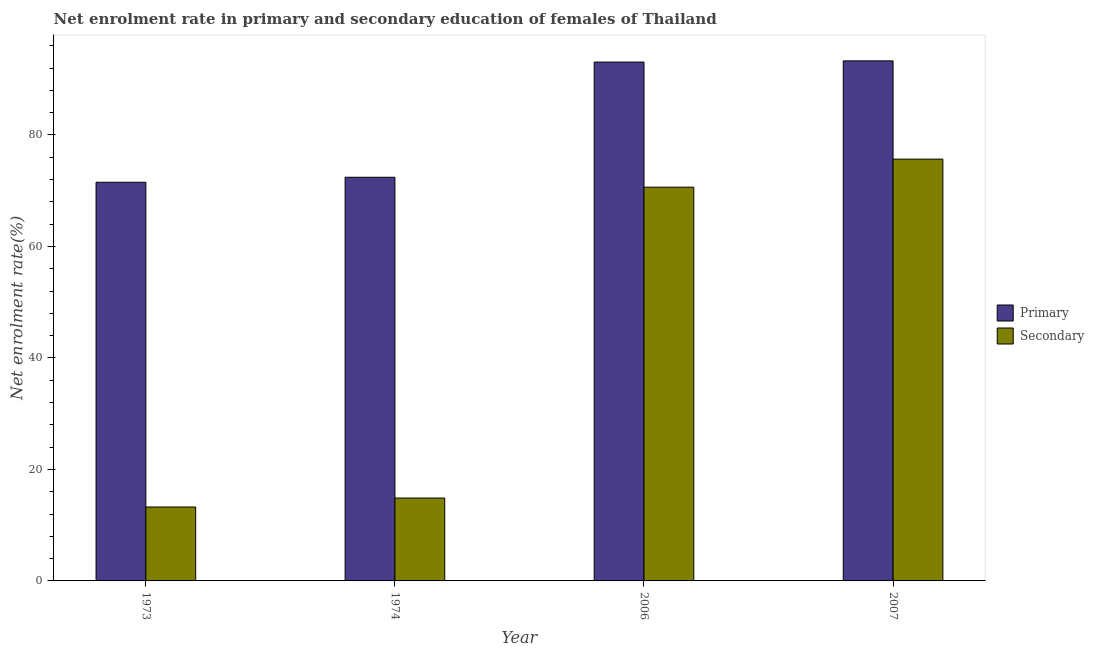How many different coloured bars are there?
Keep it short and to the point. 2. How many bars are there on the 1st tick from the left?
Your answer should be very brief. 2. How many bars are there on the 4th tick from the right?
Make the answer very short. 2. What is the label of the 3rd group of bars from the left?
Your answer should be very brief. 2006. In how many cases, is the number of bars for a given year not equal to the number of legend labels?
Give a very brief answer. 0. What is the enrollment rate in secondary education in 2007?
Keep it short and to the point. 75.66. Across all years, what is the maximum enrollment rate in primary education?
Provide a succinct answer. 93.28. Across all years, what is the minimum enrollment rate in secondary education?
Your answer should be compact. 13.26. In which year was the enrollment rate in primary education maximum?
Your response must be concise. 2007. In which year was the enrollment rate in secondary education minimum?
Provide a short and direct response. 1973. What is the total enrollment rate in secondary education in the graph?
Make the answer very short. 174.42. What is the difference between the enrollment rate in primary education in 1974 and that in 2006?
Offer a very short reply. -20.66. What is the difference between the enrollment rate in primary education in 1973 and the enrollment rate in secondary education in 2007?
Keep it short and to the point. -21.77. What is the average enrollment rate in primary education per year?
Give a very brief answer. 82.57. In the year 2006, what is the difference between the enrollment rate in primary education and enrollment rate in secondary education?
Ensure brevity in your answer.  0. What is the ratio of the enrollment rate in secondary education in 2006 to that in 2007?
Provide a succinct answer. 0.93. Is the enrollment rate in primary education in 1973 less than that in 2006?
Provide a succinct answer. Yes. Is the difference between the enrollment rate in secondary education in 2006 and 2007 greater than the difference between the enrollment rate in primary education in 2006 and 2007?
Offer a very short reply. No. What is the difference between the highest and the second highest enrollment rate in secondary education?
Your answer should be very brief. 5.03. What is the difference between the highest and the lowest enrollment rate in secondary education?
Keep it short and to the point. 62.4. In how many years, is the enrollment rate in secondary education greater than the average enrollment rate in secondary education taken over all years?
Your response must be concise. 2. Is the sum of the enrollment rate in primary education in 2006 and 2007 greater than the maximum enrollment rate in secondary education across all years?
Offer a very short reply. Yes. What does the 1st bar from the left in 2006 represents?
Your answer should be compact. Primary. What does the 2nd bar from the right in 1974 represents?
Provide a succinct answer. Primary. How many years are there in the graph?
Make the answer very short. 4. What is the difference between two consecutive major ticks on the Y-axis?
Offer a very short reply. 20. Does the graph contain grids?
Provide a short and direct response. No. How are the legend labels stacked?
Provide a succinct answer. Vertical. What is the title of the graph?
Make the answer very short. Net enrolment rate in primary and secondary education of females of Thailand. What is the label or title of the X-axis?
Provide a succinct answer. Year. What is the label or title of the Y-axis?
Provide a short and direct response. Net enrolment rate(%). What is the Net enrolment rate(%) in Primary in 1973?
Make the answer very short. 71.51. What is the Net enrolment rate(%) in Secondary in 1973?
Your answer should be compact. 13.26. What is the Net enrolment rate(%) of Primary in 1974?
Make the answer very short. 72.41. What is the Net enrolment rate(%) of Secondary in 1974?
Make the answer very short. 14.87. What is the Net enrolment rate(%) of Primary in 2006?
Your response must be concise. 93.07. What is the Net enrolment rate(%) in Secondary in 2006?
Make the answer very short. 70.63. What is the Net enrolment rate(%) of Primary in 2007?
Your response must be concise. 93.28. What is the Net enrolment rate(%) of Secondary in 2007?
Make the answer very short. 75.66. Across all years, what is the maximum Net enrolment rate(%) of Primary?
Provide a succinct answer. 93.28. Across all years, what is the maximum Net enrolment rate(%) in Secondary?
Provide a short and direct response. 75.66. Across all years, what is the minimum Net enrolment rate(%) in Primary?
Keep it short and to the point. 71.51. Across all years, what is the minimum Net enrolment rate(%) in Secondary?
Make the answer very short. 13.26. What is the total Net enrolment rate(%) in Primary in the graph?
Keep it short and to the point. 330.27. What is the total Net enrolment rate(%) of Secondary in the graph?
Your answer should be compact. 174.42. What is the difference between the Net enrolment rate(%) in Primary in 1973 and that in 1974?
Keep it short and to the point. -0.89. What is the difference between the Net enrolment rate(%) in Secondary in 1973 and that in 1974?
Provide a short and direct response. -1.61. What is the difference between the Net enrolment rate(%) in Primary in 1973 and that in 2006?
Your response must be concise. -21.56. What is the difference between the Net enrolment rate(%) of Secondary in 1973 and that in 2006?
Offer a very short reply. -57.37. What is the difference between the Net enrolment rate(%) in Primary in 1973 and that in 2007?
Offer a terse response. -21.77. What is the difference between the Net enrolment rate(%) of Secondary in 1973 and that in 2007?
Your answer should be compact. -62.4. What is the difference between the Net enrolment rate(%) of Primary in 1974 and that in 2006?
Your answer should be compact. -20.66. What is the difference between the Net enrolment rate(%) in Secondary in 1974 and that in 2006?
Your response must be concise. -55.76. What is the difference between the Net enrolment rate(%) in Primary in 1974 and that in 2007?
Keep it short and to the point. -20.88. What is the difference between the Net enrolment rate(%) of Secondary in 1974 and that in 2007?
Give a very brief answer. -60.8. What is the difference between the Net enrolment rate(%) in Primary in 2006 and that in 2007?
Your answer should be very brief. -0.22. What is the difference between the Net enrolment rate(%) of Secondary in 2006 and that in 2007?
Your answer should be compact. -5.03. What is the difference between the Net enrolment rate(%) of Primary in 1973 and the Net enrolment rate(%) of Secondary in 1974?
Provide a succinct answer. 56.64. What is the difference between the Net enrolment rate(%) of Primary in 1973 and the Net enrolment rate(%) of Secondary in 2006?
Provide a short and direct response. 0.88. What is the difference between the Net enrolment rate(%) in Primary in 1973 and the Net enrolment rate(%) in Secondary in 2007?
Make the answer very short. -4.15. What is the difference between the Net enrolment rate(%) of Primary in 1974 and the Net enrolment rate(%) of Secondary in 2006?
Your answer should be very brief. 1.78. What is the difference between the Net enrolment rate(%) of Primary in 1974 and the Net enrolment rate(%) of Secondary in 2007?
Offer a very short reply. -3.26. What is the difference between the Net enrolment rate(%) in Primary in 2006 and the Net enrolment rate(%) in Secondary in 2007?
Offer a terse response. 17.41. What is the average Net enrolment rate(%) of Primary per year?
Provide a short and direct response. 82.57. What is the average Net enrolment rate(%) in Secondary per year?
Give a very brief answer. 43.61. In the year 1973, what is the difference between the Net enrolment rate(%) in Primary and Net enrolment rate(%) in Secondary?
Your response must be concise. 58.25. In the year 1974, what is the difference between the Net enrolment rate(%) of Primary and Net enrolment rate(%) of Secondary?
Keep it short and to the point. 57.54. In the year 2006, what is the difference between the Net enrolment rate(%) of Primary and Net enrolment rate(%) of Secondary?
Make the answer very short. 22.44. In the year 2007, what is the difference between the Net enrolment rate(%) in Primary and Net enrolment rate(%) in Secondary?
Make the answer very short. 17.62. What is the ratio of the Net enrolment rate(%) in Primary in 1973 to that in 1974?
Provide a succinct answer. 0.99. What is the ratio of the Net enrolment rate(%) in Secondary in 1973 to that in 1974?
Give a very brief answer. 0.89. What is the ratio of the Net enrolment rate(%) of Primary in 1973 to that in 2006?
Your answer should be very brief. 0.77. What is the ratio of the Net enrolment rate(%) in Secondary in 1973 to that in 2006?
Your answer should be compact. 0.19. What is the ratio of the Net enrolment rate(%) in Primary in 1973 to that in 2007?
Offer a very short reply. 0.77. What is the ratio of the Net enrolment rate(%) of Secondary in 1973 to that in 2007?
Make the answer very short. 0.18. What is the ratio of the Net enrolment rate(%) of Primary in 1974 to that in 2006?
Your answer should be compact. 0.78. What is the ratio of the Net enrolment rate(%) of Secondary in 1974 to that in 2006?
Keep it short and to the point. 0.21. What is the ratio of the Net enrolment rate(%) in Primary in 1974 to that in 2007?
Your answer should be very brief. 0.78. What is the ratio of the Net enrolment rate(%) of Secondary in 1974 to that in 2007?
Provide a short and direct response. 0.2. What is the ratio of the Net enrolment rate(%) of Primary in 2006 to that in 2007?
Your answer should be compact. 1. What is the ratio of the Net enrolment rate(%) in Secondary in 2006 to that in 2007?
Provide a succinct answer. 0.93. What is the difference between the highest and the second highest Net enrolment rate(%) of Primary?
Offer a terse response. 0.22. What is the difference between the highest and the second highest Net enrolment rate(%) in Secondary?
Make the answer very short. 5.03. What is the difference between the highest and the lowest Net enrolment rate(%) in Primary?
Offer a terse response. 21.77. What is the difference between the highest and the lowest Net enrolment rate(%) in Secondary?
Offer a very short reply. 62.4. 